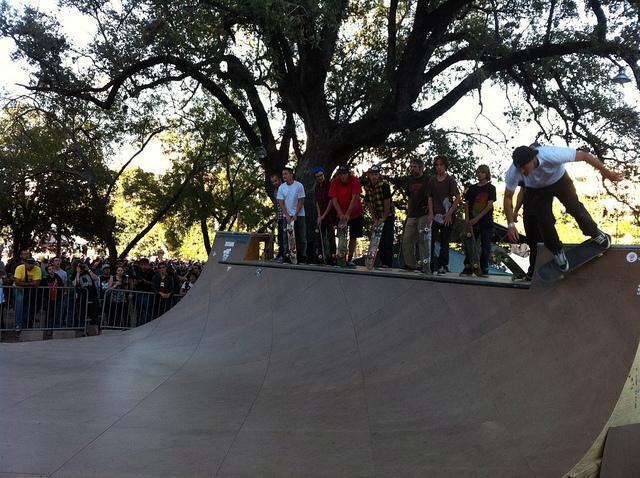How many people are on the ramp?
Select the accurate answer and provide justification: `Answer: choice
Rationale: srationale.`
Options: Four, two, one, many. Answer: many.
Rationale: There are a lot of people up there. 